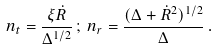<formula> <loc_0><loc_0><loc_500><loc_500>n _ { t } = \frac { \xi \dot { R } } { \Delta ^ { 1 / 2 } } \, ; \, n _ { r } = \frac { ( \Delta + \dot { R } ^ { 2 } ) ^ { 1 / 2 } } { \Delta } \, .</formula> 